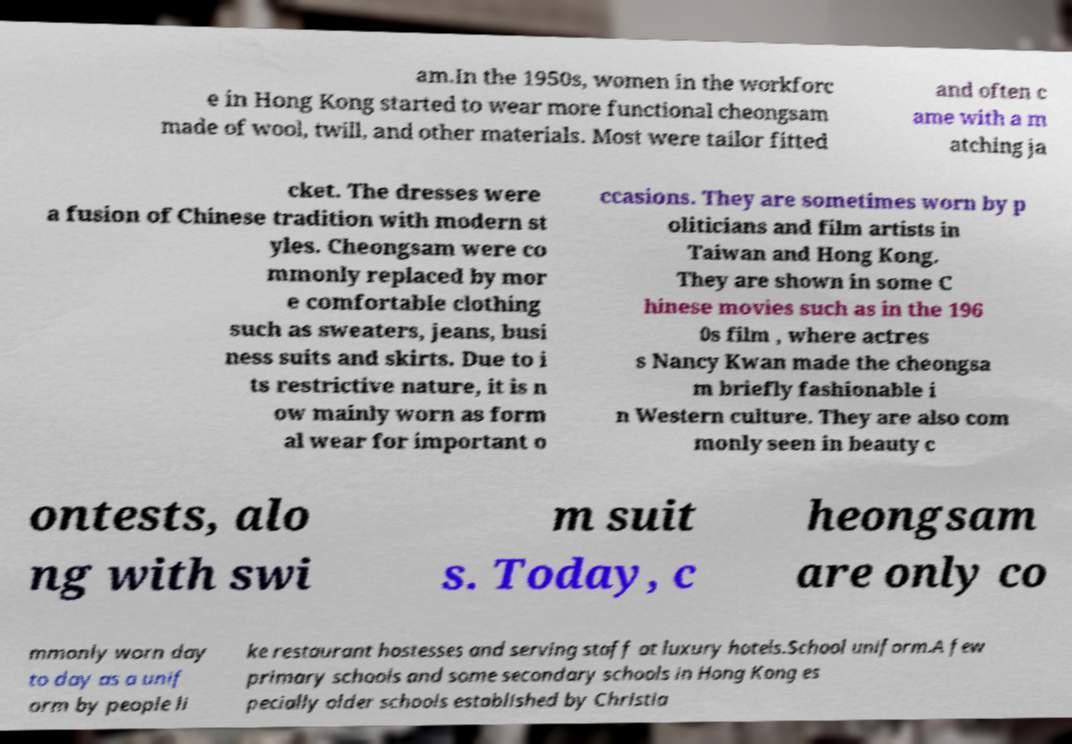Could you extract and type out the text from this image? am.In the 1950s, women in the workforc e in Hong Kong started to wear more functional cheongsam made of wool, twill, and other materials. Most were tailor fitted and often c ame with a m atching ja cket. The dresses were a fusion of Chinese tradition with modern st yles. Cheongsam were co mmonly replaced by mor e comfortable clothing such as sweaters, jeans, busi ness suits and skirts. Due to i ts restrictive nature, it is n ow mainly worn as form al wear for important o ccasions. They are sometimes worn by p oliticians and film artists in Taiwan and Hong Kong. They are shown in some C hinese movies such as in the 196 0s film , where actres s Nancy Kwan made the cheongsa m briefly fashionable i n Western culture. They are also com monly seen in beauty c ontests, alo ng with swi m suit s. Today, c heongsam are only co mmonly worn day to day as a unif orm by people li ke restaurant hostesses and serving staff at luxury hotels.School uniform.A few primary schools and some secondary schools in Hong Kong es pecially older schools established by Christia 